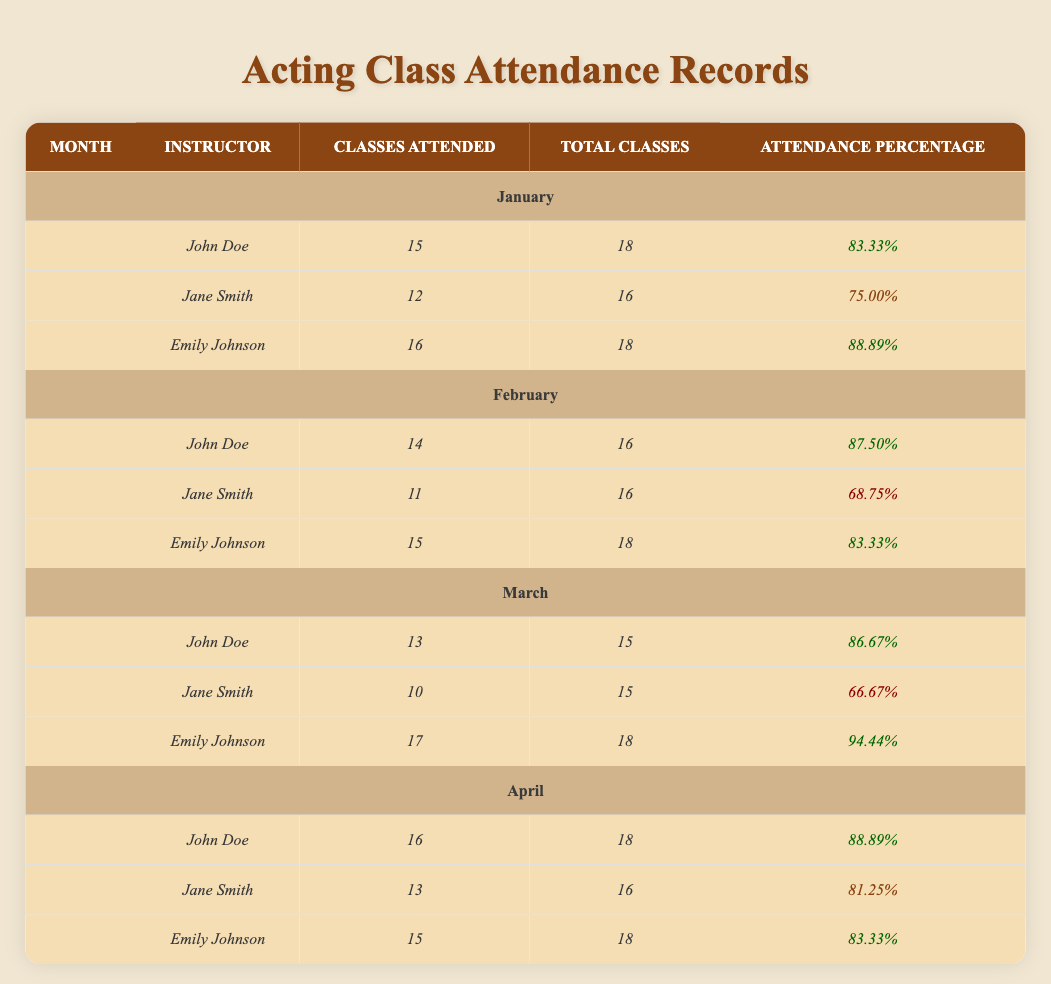What was Emily Johnson's attendance percentage in March? Emily Johnson's attendance percentage for March is listed in the table under that month, showing that she attended 17 out of 18 classes. The attendance percentage is noted as 94.44%.
Answer: 94.44% How many classes did Jane Smith attend in February? In February, Jane Smith attended 11 classes, as per the data presented in the table for that month.
Answer: 11 Which instructor had the highest attendance percentage in April? To find the instructor with the highest attendance percentage in April, compare the percentages listed for each instructor in that month: John Doe had 88.89%, Jane Smith had 81.25%, and Emily Johnson had 83.33%. John Doe had the highest attendance percentage.
Answer: John Doe What is the average attendance percentage for John Doe over the four months? First, gather the attendance percentages for John Doe: 83.33% in January, 87.50% in February, 86.67% in March, and 88.89% in April. Calculate the average by summing these percentages (83.33 + 87.50 + 86.67 + 88.89 = 346.39) and dividing by 4 (346.39/4 = 86.5975), rounding to two decimal places gives 86.60%.
Answer: 86.60% Did any instructor have an attendance percentage of 66.67%? The table details Jane Smith's attendance percentage in March as 66.67%. Thus, the statement is true; at least one instructor (Jane Smith) had an attendance percentage of 66.67%.
Answer: Yes 